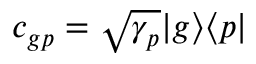Convert formula to latex. <formula><loc_0><loc_0><loc_500><loc_500>c _ { g p } = \sqrt { \gamma _ { p } } | g \rangle \langle p |</formula> 